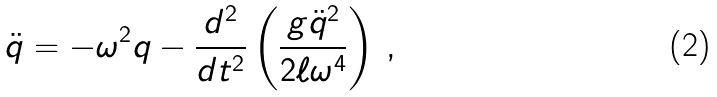<formula> <loc_0><loc_0><loc_500><loc_500>\ddot { q } = - \omega ^ { 2 } q - \frac { d ^ { 2 } } { d t ^ { 2 } } \left ( \frac { g \ddot { q } ^ { 2 } } { 2 \ell \omega ^ { 4 } } \right ) \, ,</formula> 